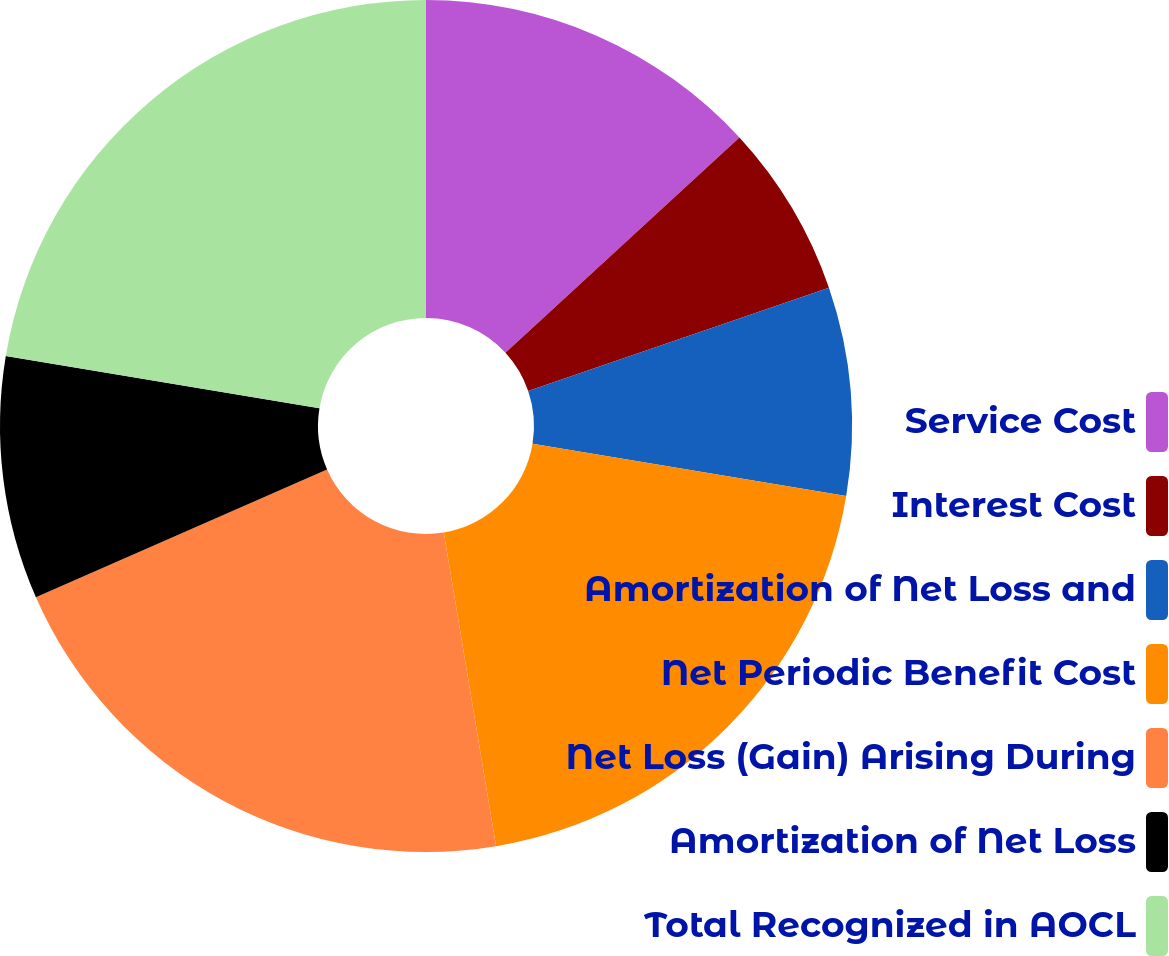Convert chart. <chart><loc_0><loc_0><loc_500><loc_500><pie_chart><fcel>Service Cost<fcel>Interest Cost<fcel>Amortization of Net Loss and<fcel>Net Periodic Benefit Cost<fcel>Net Loss (Gain) Arising During<fcel>Amortization of Net Loss<fcel>Total Recognized in AOCL<nl><fcel>13.16%<fcel>6.58%<fcel>7.89%<fcel>19.74%<fcel>21.05%<fcel>9.21%<fcel>22.37%<nl></chart> 